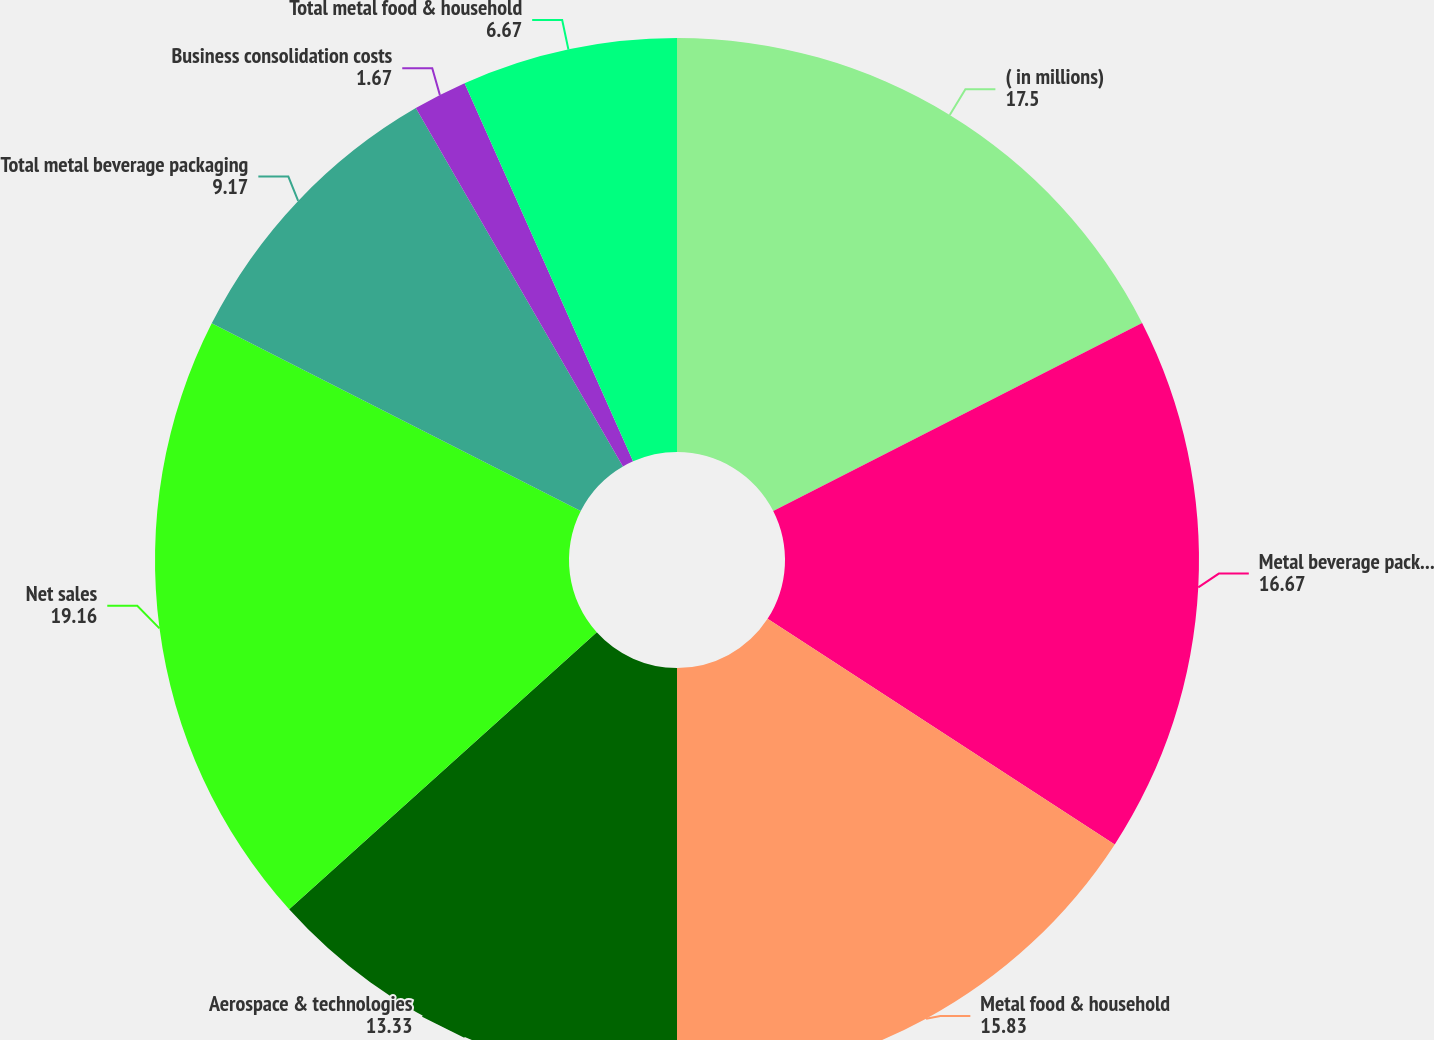Convert chart. <chart><loc_0><loc_0><loc_500><loc_500><pie_chart><fcel>( in millions)<fcel>Metal beverage packaging<fcel>Metal food & household<fcel>Aerospace & technologies<fcel>Net sales<fcel>Total metal beverage packaging<fcel>Business consolidation costs<fcel>Total metal food & household<nl><fcel>17.5%<fcel>16.67%<fcel>15.83%<fcel>13.33%<fcel>19.16%<fcel>9.17%<fcel>1.67%<fcel>6.67%<nl></chart> 